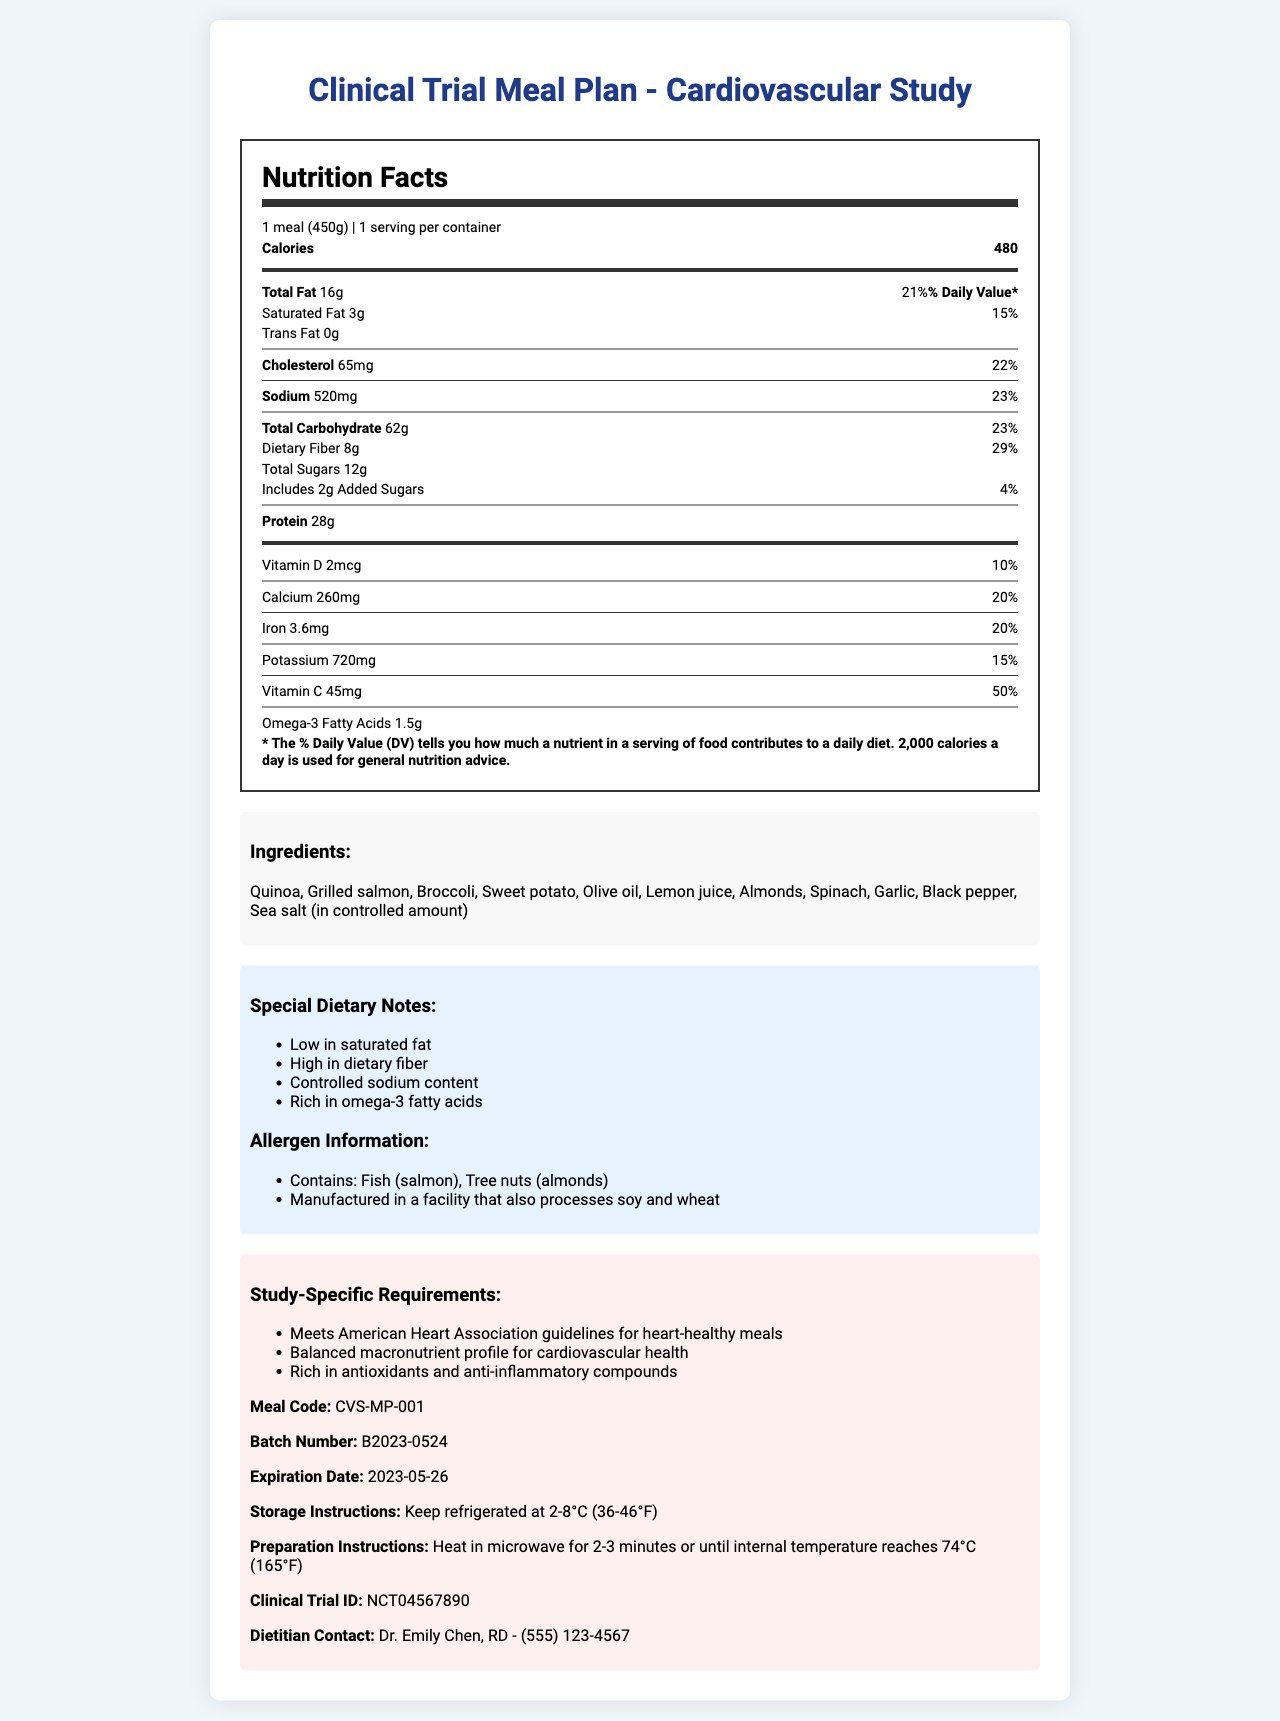what is the serving size of the meal? The serving size is mentioned at the top of the Nutrition Facts section.
Answer: 1 meal (450g) How many calories are in one serving of this meal? The number of calories per serving is listed under the Nutrition Facts section as 480.
Answer: 480 calories What is the amount of sodium in this meal? The sodium amount is shown in the Nutrition Facts section as 520mg.
Answer: 520mg What is the daily value percentage of dietary fiber for this meal? The percentage of daily value for dietary fiber is listed as 29% under the Nutrition Facts section.
Answer: 29% What types of allergens does this meal contain? The allergen information section lists fish (salmon) and tree nuts (almonds) as the allergens.
Answer: Fish (salmon), Tree nuts (almonds) Which of the following components is not included in the meal preparation instructions? A. Refrigerate B. Freeze C. Microwave The preparation instructions specify heating in the microwave and keeping the meal refrigerated, but do not mention freezing.
Answer: B Which nutrient has the highest daily value percentage? A. Vitamin D B. Calcium C. Vitamin C D. Dietary Fiber Vitamin C has the highest daily value percentage at 50%, followed by dietary fiber at 29%.
Answer: C Is this meal suitable for someone with a wheat allergen? The meal is manufactured in a facility that processes wheat, which is disclosed in the allergen information section.
Answer: No Summarize the main attributes of this meal plan. The document describes a meal plan designed for a cardiovascular study, outlining nutritional content, ingredients, special dietary notes, and allergen warnings. It also lists preparation and storage instructions, batch information, and clinical trial details.
Answer: The Clinical Trial Meal Plan - Cardiovascular Study provides a heart-healthy meal with balanced macronutrients, high dietary fiber, and controlled sodium content. It includes quinoa, grilled salmon, and vegetables, and is suitable for cardiovascular health studies. It has specific dietary notes and meets American Heart Association guidelines. Allergen information is provided. What is the impact of this meal on omega-3 fatty acid intake? The document notes that the meal is rich in omega-3 fatty acids, and the Nutrition Facts label confirms it provides 1.5g of omega-3s.
Answer: It is rich in omega-3 fatty acids, providing 1.5g per serving. What is the expiration date of the meal? The expiration date is listed under the study-specific requirements section as 2023-05-26.
Answer: May 26, 2023 Who should you contact if you have questions about the meal's nutrition facts? The dietitian contact provided at the end of the document is Dr. Emily Chen, RD, with a phone number.
Answer: Dr. Emily Chen, RD - (555) 123-4567 Does the meal include added sugars? The Nutrition Facts section indicates that the meal includes 2g of added sugars, which makes up 4% of the daily value.
Answer: Yes Is there information about the exact clinical trial this meal is prepared for? The document provides a specific Clinical Trial ID: NCT04567890 under the study-specific requirements section.
Answer: Yes, Clinical Trial ID: NCT04567890 What are the specific dietary notes for this meal? The special dietary notes section lists these attributes.
Answer: Low in saturated fat, High in dietary fiber, Controlled sodium content, Rich in omega-3 fatty acids What is the balanced macronutrient profile aimed at? The study-specific requirements state that the meal has a balanced macronutrient profile aimed at cardiovascular health.
Answer: Cardiovascular health What other types of products are manufactured in the facility? The document only mentions that the facility also processes soy and wheat, but does not provide information on other specific products.
Answer: Cannot be determined 